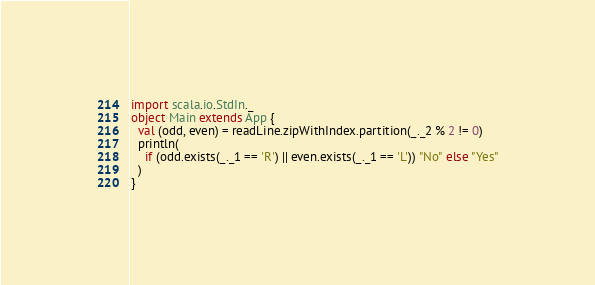Convert code to text. <code><loc_0><loc_0><loc_500><loc_500><_Scala_>import scala.io.StdIn._
object Main extends App {
  val (odd, even) = readLine.zipWithIndex.partition(_._2 % 2 != 0)
  println(
    if (odd.exists(_._1 == 'R') || even.exists(_._1 == 'L')) "No" else "Yes"
  )
}
</code> 